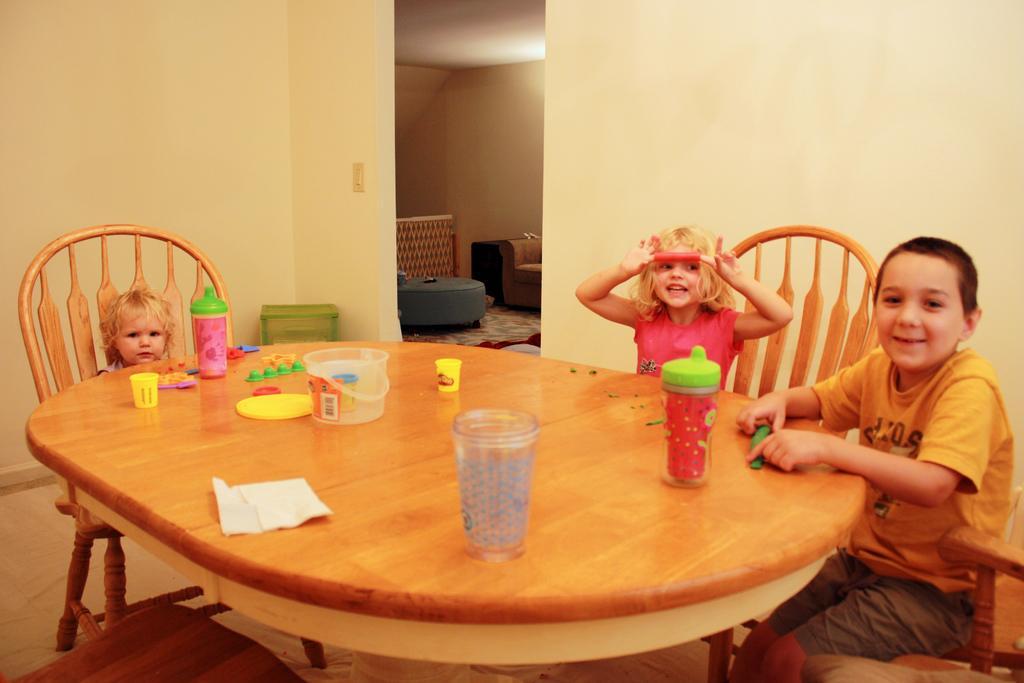In one or two sentences, can you explain what this image depicts? there is a table on which there are glass, bottles. on 3 chairs 3 people are sitting. behind them there are walls. in the next room there is a sofa. 